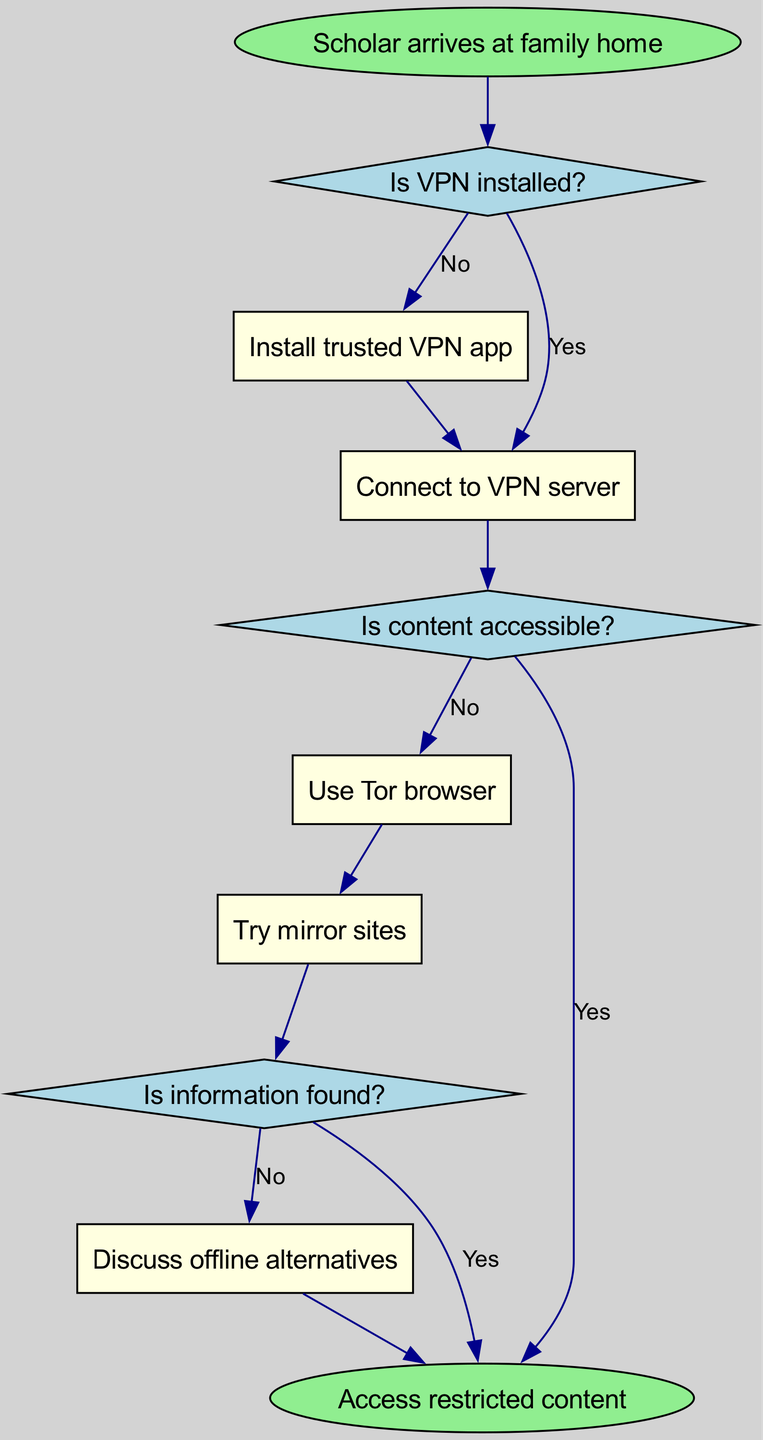What is the starting point of the flow chart? The flow chart starts at the node labeled "Scholar arrives at family home." This information is explicitly stated as the starting point in the diagram.
Answer: Scholar arrives at family home How many decision nodes are in the diagram? There are three decision nodes in the flow chart: "Is VPN installed?", "Is content accessible?", and "Is information found?" By counting these nodes, we can confirm the total.
Answer: 3 What action occurs if the VPN is not installed? If the VPN is not installed, the action is to "Install trusted VPN app." This is directly indicated in the flow chart as the next step after the first decision.
Answer: Install trusted VPN app What happens if the content is accessible? If the content is accessible, the next step is to reach the end node labeled "Access restricted content." This is illustrated in the flow chart following the second decision.
Answer: Access restricted content What action is taken if the content is not found after trying mirror sites? If no information is found after trying mirror sites, the action taken is to "Discuss offline alternatives." This follows from the decision operations illustrated in the flow.
Answer: Discuss offline alternatives What is the consequence of connecting to a VPN server? Connecting to a VPN server leads to checking whether the content is accessible. This connection is a necessary step to reach the subsequent decision node regarding accessibility.
Answer: Check content accessibility Which action is linked to the decision "Is information found?"? The actions linked to the decision "Is information found?" are "Discuss offline alternatives" if no information is found and the end labeled "Access restricted content" if information is found. This relationship is clearly defined in the flow.
Answer: Discuss offline alternatives and Access restricted content What is the flow after installing the VPN app? After installing the VPN app, the flow continues to "Connect to VPN server." This step is necessary and directly follows the action of installation based on the diagram's sequence.
Answer: Connect to VPN server What are the possible actions after determining content accessibility? After determining content accessibility, the possible actions are to either "Use Tor browser" if content is not accessible or to reach the "Access restricted content" if it is accessible. This creates a branching path in the flow.
Answer: Use Tor browser or Access restricted content 